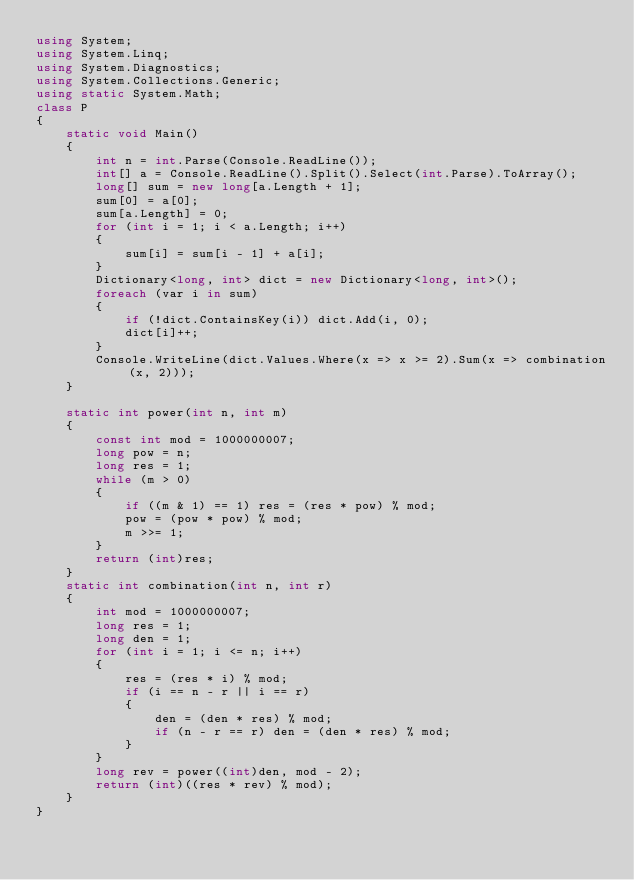Convert code to text. <code><loc_0><loc_0><loc_500><loc_500><_C#_>using System;
using System.Linq;
using System.Diagnostics;
using System.Collections.Generic;
using static System.Math;
class P
{
    static void Main()
    {
        int n = int.Parse(Console.ReadLine());
        int[] a = Console.ReadLine().Split().Select(int.Parse).ToArray();
        long[] sum = new long[a.Length + 1];
        sum[0] = a[0];
        sum[a.Length] = 0;
        for (int i = 1; i < a.Length; i++)
        {
            sum[i] = sum[i - 1] + a[i];
        }
        Dictionary<long, int> dict = new Dictionary<long, int>();
        foreach (var i in sum)
        {
            if (!dict.ContainsKey(i)) dict.Add(i, 0);
            dict[i]++;
        }
        Console.WriteLine(dict.Values.Where(x => x >= 2).Sum(x => combination(x, 2)));
    }

    static int power(int n, int m)
    {
        const int mod = 1000000007;
        long pow = n;
        long res = 1;
        while (m > 0)
        {
            if ((m & 1) == 1) res = (res * pow) % mod;
            pow = (pow * pow) % mod;
            m >>= 1;
        }
        return (int)res;
    }
    static int combination(int n, int r)
    {
        int mod = 1000000007;
        long res = 1;
        long den = 1;
        for (int i = 1; i <= n; i++)
        {
            res = (res * i) % mod;
            if (i == n - r || i == r)
            {
                den = (den * res) % mod;
                if (n - r == r) den = (den * res) % mod;
            }
        }
        long rev = power((int)den, mod - 2);
        return (int)((res * rev) % mod);
    }
}</code> 